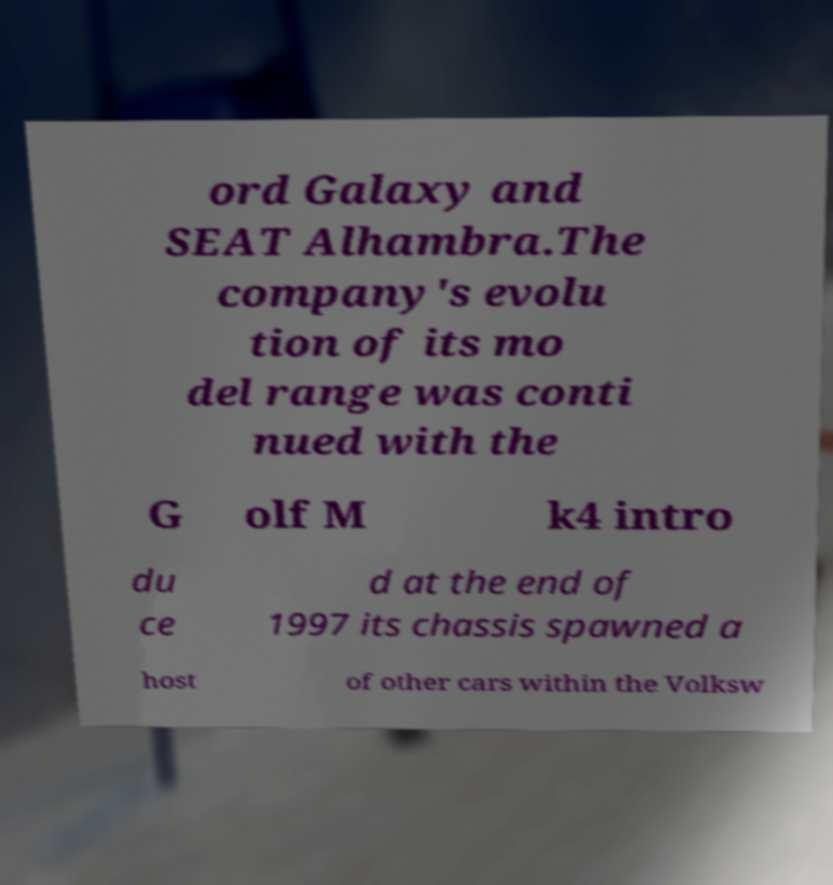There's text embedded in this image that I need extracted. Can you transcribe it verbatim? ord Galaxy and SEAT Alhambra.The company's evolu tion of its mo del range was conti nued with the G olf M k4 intro du ce d at the end of 1997 its chassis spawned a host of other cars within the Volksw 